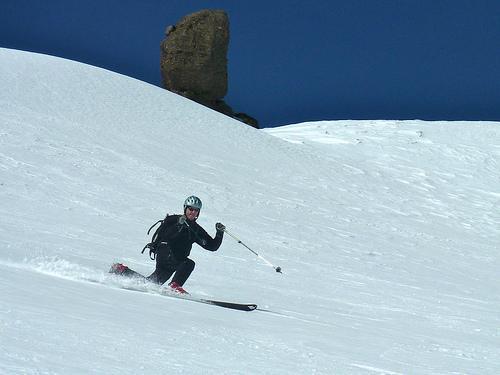How many large rocks are there?
Give a very brief answer. 1. How many people skiing?
Give a very brief answer. 1. How many people are in the picture?
Give a very brief answer. 1. 